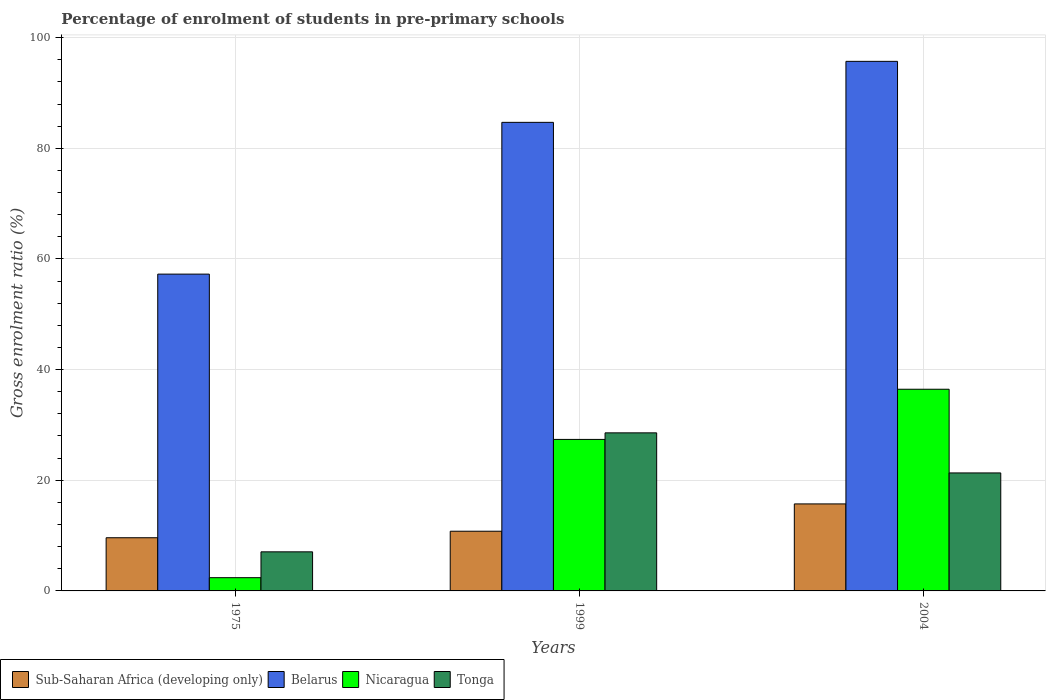How many different coloured bars are there?
Make the answer very short. 4. How many groups of bars are there?
Provide a short and direct response. 3. Are the number of bars per tick equal to the number of legend labels?
Provide a succinct answer. Yes. How many bars are there on the 1st tick from the left?
Offer a very short reply. 4. How many bars are there on the 2nd tick from the right?
Ensure brevity in your answer.  4. What is the label of the 1st group of bars from the left?
Your answer should be compact. 1975. In how many cases, is the number of bars for a given year not equal to the number of legend labels?
Offer a very short reply. 0. What is the percentage of students enrolled in pre-primary schools in Sub-Saharan Africa (developing only) in 1975?
Your response must be concise. 9.61. Across all years, what is the maximum percentage of students enrolled in pre-primary schools in Sub-Saharan Africa (developing only)?
Make the answer very short. 15.73. Across all years, what is the minimum percentage of students enrolled in pre-primary schools in Sub-Saharan Africa (developing only)?
Give a very brief answer. 9.61. In which year was the percentage of students enrolled in pre-primary schools in Sub-Saharan Africa (developing only) minimum?
Keep it short and to the point. 1975. What is the total percentage of students enrolled in pre-primary schools in Belarus in the graph?
Make the answer very short. 237.65. What is the difference between the percentage of students enrolled in pre-primary schools in Sub-Saharan Africa (developing only) in 1975 and that in 1999?
Ensure brevity in your answer.  -1.18. What is the difference between the percentage of students enrolled in pre-primary schools in Sub-Saharan Africa (developing only) in 1975 and the percentage of students enrolled in pre-primary schools in Nicaragua in 1999?
Provide a short and direct response. -17.77. What is the average percentage of students enrolled in pre-primary schools in Tonga per year?
Make the answer very short. 18.99. In the year 2004, what is the difference between the percentage of students enrolled in pre-primary schools in Belarus and percentage of students enrolled in pre-primary schools in Sub-Saharan Africa (developing only)?
Offer a terse response. 79.98. What is the ratio of the percentage of students enrolled in pre-primary schools in Nicaragua in 1999 to that in 2004?
Your response must be concise. 0.75. Is the difference between the percentage of students enrolled in pre-primary schools in Belarus in 1999 and 2004 greater than the difference between the percentage of students enrolled in pre-primary schools in Sub-Saharan Africa (developing only) in 1999 and 2004?
Offer a very short reply. No. What is the difference between the highest and the second highest percentage of students enrolled in pre-primary schools in Sub-Saharan Africa (developing only)?
Offer a very short reply. 4.94. What is the difference between the highest and the lowest percentage of students enrolled in pre-primary schools in Tonga?
Provide a short and direct response. 21.51. Is it the case that in every year, the sum of the percentage of students enrolled in pre-primary schools in Tonga and percentage of students enrolled in pre-primary schools in Sub-Saharan Africa (developing only) is greater than the sum of percentage of students enrolled in pre-primary schools in Belarus and percentage of students enrolled in pre-primary schools in Nicaragua?
Your answer should be compact. No. What does the 3rd bar from the left in 1975 represents?
Your answer should be very brief. Nicaragua. What does the 3rd bar from the right in 2004 represents?
Give a very brief answer. Belarus. Is it the case that in every year, the sum of the percentage of students enrolled in pre-primary schools in Sub-Saharan Africa (developing only) and percentage of students enrolled in pre-primary schools in Belarus is greater than the percentage of students enrolled in pre-primary schools in Tonga?
Ensure brevity in your answer.  Yes. What is the difference between two consecutive major ticks on the Y-axis?
Your answer should be very brief. 20. Does the graph contain any zero values?
Ensure brevity in your answer.  No. Does the graph contain grids?
Your answer should be compact. Yes. How many legend labels are there?
Your answer should be compact. 4. How are the legend labels stacked?
Provide a short and direct response. Horizontal. What is the title of the graph?
Keep it short and to the point. Percentage of enrolment of students in pre-primary schools. What is the label or title of the X-axis?
Keep it short and to the point. Years. What is the label or title of the Y-axis?
Give a very brief answer. Gross enrolment ratio (%). What is the Gross enrolment ratio (%) of Sub-Saharan Africa (developing only) in 1975?
Make the answer very short. 9.61. What is the Gross enrolment ratio (%) in Belarus in 1975?
Provide a succinct answer. 57.26. What is the Gross enrolment ratio (%) in Nicaragua in 1975?
Keep it short and to the point. 2.39. What is the Gross enrolment ratio (%) in Tonga in 1975?
Provide a succinct answer. 7.06. What is the Gross enrolment ratio (%) of Sub-Saharan Africa (developing only) in 1999?
Your response must be concise. 10.79. What is the Gross enrolment ratio (%) in Belarus in 1999?
Ensure brevity in your answer.  84.68. What is the Gross enrolment ratio (%) in Nicaragua in 1999?
Your answer should be very brief. 27.38. What is the Gross enrolment ratio (%) in Tonga in 1999?
Your answer should be compact. 28.57. What is the Gross enrolment ratio (%) in Sub-Saharan Africa (developing only) in 2004?
Offer a very short reply. 15.73. What is the Gross enrolment ratio (%) of Belarus in 2004?
Offer a very short reply. 95.71. What is the Gross enrolment ratio (%) in Nicaragua in 2004?
Keep it short and to the point. 36.45. What is the Gross enrolment ratio (%) of Tonga in 2004?
Provide a short and direct response. 21.32. Across all years, what is the maximum Gross enrolment ratio (%) of Sub-Saharan Africa (developing only)?
Provide a succinct answer. 15.73. Across all years, what is the maximum Gross enrolment ratio (%) of Belarus?
Ensure brevity in your answer.  95.71. Across all years, what is the maximum Gross enrolment ratio (%) in Nicaragua?
Keep it short and to the point. 36.45. Across all years, what is the maximum Gross enrolment ratio (%) in Tonga?
Offer a terse response. 28.57. Across all years, what is the minimum Gross enrolment ratio (%) of Sub-Saharan Africa (developing only)?
Ensure brevity in your answer.  9.61. Across all years, what is the minimum Gross enrolment ratio (%) in Belarus?
Ensure brevity in your answer.  57.26. Across all years, what is the minimum Gross enrolment ratio (%) of Nicaragua?
Ensure brevity in your answer.  2.39. Across all years, what is the minimum Gross enrolment ratio (%) of Tonga?
Provide a short and direct response. 7.06. What is the total Gross enrolment ratio (%) of Sub-Saharan Africa (developing only) in the graph?
Ensure brevity in your answer.  36.12. What is the total Gross enrolment ratio (%) of Belarus in the graph?
Keep it short and to the point. 237.65. What is the total Gross enrolment ratio (%) of Nicaragua in the graph?
Your answer should be very brief. 66.23. What is the total Gross enrolment ratio (%) in Tonga in the graph?
Ensure brevity in your answer.  56.96. What is the difference between the Gross enrolment ratio (%) of Sub-Saharan Africa (developing only) in 1975 and that in 1999?
Keep it short and to the point. -1.18. What is the difference between the Gross enrolment ratio (%) of Belarus in 1975 and that in 1999?
Offer a terse response. -27.43. What is the difference between the Gross enrolment ratio (%) of Nicaragua in 1975 and that in 1999?
Keep it short and to the point. -24.99. What is the difference between the Gross enrolment ratio (%) in Tonga in 1975 and that in 1999?
Your response must be concise. -21.5. What is the difference between the Gross enrolment ratio (%) in Sub-Saharan Africa (developing only) in 1975 and that in 2004?
Keep it short and to the point. -6.11. What is the difference between the Gross enrolment ratio (%) of Belarus in 1975 and that in 2004?
Give a very brief answer. -38.45. What is the difference between the Gross enrolment ratio (%) in Nicaragua in 1975 and that in 2004?
Your response must be concise. -34.06. What is the difference between the Gross enrolment ratio (%) in Tonga in 1975 and that in 2004?
Give a very brief answer. -14.26. What is the difference between the Gross enrolment ratio (%) of Sub-Saharan Africa (developing only) in 1999 and that in 2004?
Offer a terse response. -4.94. What is the difference between the Gross enrolment ratio (%) of Belarus in 1999 and that in 2004?
Your answer should be compact. -11.02. What is the difference between the Gross enrolment ratio (%) of Nicaragua in 1999 and that in 2004?
Give a very brief answer. -9.07. What is the difference between the Gross enrolment ratio (%) in Tonga in 1999 and that in 2004?
Make the answer very short. 7.25. What is the difference between the Gross enrolment ratio (%) of Sub-Saharan Africa (developing only) in 1975 and the Gross enrolment ratio (%) of Belarus in 1999?
Provide a short and direct response. -75.07. What is the difference between the Gross enrolment ratio (%) of Sub-Saharan Africa (developing only) in 1975 and the Gross enrolment ratio (%) of Nicaragua in 1999?
Your answer should be very brief. -17.77. What is the difference between the Gross enrolment ratio (%) of Sub-Saharan Africa (developing only) in 1975 and the Gross enrolment ratio (%) of Tonga in 1999?
Ensure brevity in your answer.  -18.96. What is the difference between the Gross enrolment ratio (%) of Belarus in 1975 and the Gross enrolment ratio (%) of Nicaragua in 1999?
Your answer should be very brief. 29.87. What is the difference between the Gross enrolment ratio (%) in Belarus in 1975 and the Gross enrolment ratio (%) in Tonga in 1999?
Give a very brief answer. 28.69. What is the difference between the Gross enrolment ratio (%) in Nicaragua in 1975 and the Gross enrolment ratio (%) in Tonga in 1999?
Your answer should be compact. -26.18. What is the difference between the Gross enrolment ratio (%) of Sub-Saharan Africa (developing only) in 1975 and the Gross enrolment ratio (%) of Belarus in 2004?
Offer a very short reply. -86.1. What is the difference between the Gross enrolment ratio (%) of Sub-Saharan Africa (developing only) in 1975 and the Gross enrolment ratio (%) of Nicaragua in 2004?
Provide a succinct answer. -26.84. What is the difference between the Gross enrolment ratio (%) of Sub-Saharan Africa (developing only) in 1975 and the Gross enrolment ratio (%) of Tonga in 2004?
Your answer should be very brief. -11.71. What is the difference between the Gross enrolment ratio (%) in Belarus in 1975 and the Gross enrolment ratio (%) in Nicaragua in 2004?
Make the answer very short. 20.81. What is the difference between the Gross enrolment ratio (%) of Belarus in 1975 and the Gross enrolment ratio (%) of Tonga in 2004?
Your response must be concise. 35.93. What is the difference between the Gross enrolment ratio (%) of Nicaragua in 1975 and the Gross enrolment ratio (%) of Tonga in 2004?
Give a very brief answer. -18.93. What is the difference between the Gross enrolment ratio (%) in Sub-Saharan Africa (developing only) in 1999 and the Gross enrolment ratio (%) in Belarus in 2004?
Give a very brief answer. -84.92. What is the difference between the Gross enrolment ratio (%) in Sub-Saharan Africa (developing only) in 1999 and the Gross enrolment ratio (%) in Nicaragua in 2004?
Your response must be concise. -25.66. What is the difference between the Gross enrolment ratio (%) of Sub-Saharan Africa (developing only) in 1999 and the Gross enrolment ratio (%) of Tonga in 2004?
Your response must be concise. -10.54. What is the difference between the Gross enrolment ratio (%) in Belarus in 1999 and the Gross enrolment ratio (%) in Nicaragua in 2004?
Provide a short and direct response. 48.23. What is the difference between the Gross enrolment ratio (%) of Belarus in 1999 and the Gross enrolment ratio (%) of Tonga in 2004?
Give a very brief answer. 63.36. What is the difference between the Gross enrolment ratio (%) of Nicaragua in 1999 and the Gross enrolment ratio (%) of Tonga in 2004?
Provide a succinct answer. 6.06. What is the average Gross enrolment ratio (%) in Sub-Saharan Africa (developing only) per year?
Keep it short and to the point. 12.04. What is the average Gross enrolment ratio (%) in Belarus per year?
Offer a terse response. 79.22. What is the average Gross enrolment ratio (%) of Nicaragua per year?
Give a very brief answer. 22.08. What is the average Gross enrolment ratio (%) in Tonga per year?
Your answer should be compact. 18.99. In the year 1975, what is the difference between the Gross enrolment ratio (%) of Sub-Saharan Africa (developing only) and Gross enrolment ratio (%) of Belarus?
Provide a short and direct response. -47.64. In the year 1975, what is the difference between the Gross enrolment ratio (%) in Sub-Saharan Africa (developing only) and Gross enrolment ratio (%) in Nicaragua?
Give a very brief answer. 7.22. In the year 1975, what is the difference between the Gross enrolment ratio (%) of Sub-Saharan Africa (developing only) and Gross enrolment ratio (%) of Tonga?
Provide a short and direct response. 2.55. In the year 1975, what is the difference between the Gross enrolment ratio (%) in Belarus and Gross enrolment ratio (%) in Nicaragua?
Offer a terse response. 54.86. In the year 1975, what is the difference between the Gross enrolment ratio (%) of Belarus and Gross enrolment ratio (%) of Tonga?
Keep it short and to the point. 50.19. In the year 1975, what is the difference between the Gross enrolment ratio (%) in Nicaragua and Gross enrolment ratio (%) in Tonga?
Your answer should be compact. -4.67. In the year 1999, what is the difference between the Gross enrolment ratio (%) in Sub-Saharan Africa (developing only) and Gross enrolment ratio (%) in Belarus?
Your answer should be very brief. -73.9. In the year 1999, what is the difference between the Gross enrolment ratio (%) of Sub-Saharan Africa (developing only) and Gross enrolment ratio (%) of Nicaragua?
Give a very brief answer. -16.6. In the year 1999, what is the difference between the Gross enrolment ratio (%) of Sub-Saharan Africa (developing only) and Gross enrolment ratio (%) of Tonga?
Provide a succinct answer. -17.78. In the year 1999, what is the difference between the Gross enrolment ratio (%) in Belarus and Gross enrolment ratio (%) in Nicaragua?
Offer a terse response. 57.3. In the year 1999, what is the difference between the Gross enrolment ratio (%) of Belarus and Gross enrolment ratio (%) of Tonga?
Make the answer very short. 56.12. In the year 1999, what is the difference between the Gross enrolment ratio (%) of Nicaragua and Gross enrolment ratio (%) of Tonga?
Your answer should be very brief. -1.19. In the year 2004, what is the difference between the Gross enrolment ratio (%) of Sub-Saharan Africa (developing only) and Gross enrolment ratio (%) of Belarus?
Offer a terse response. -79.98. In the year 2004, what is the difference between the Gross enrolment ratio (%) of Sub-Saharan Africa (developing only) and Gross enrolment ratio (%) of Nicaragua?
Provide a short and direct response. -20.73. In the year 2004, what is the difference between the Gross enrolment ratio (%) in Sub-Saharan Africa (developing only) and Gross enrolment ratio (%) in Tonga?
Your answer should be very brief. -5.6. In the year 2004, what is the difference between the Gross enrolment ratio (%) in Belarus and Gross enrolment ratio (%) in Nicaragua?
Your answer should be very brief. 59.26. In the year 2004, what is the difference between the Gross enrolment ratio (%) in Belarus and Gross enrolment ratio (%) in Tonga?
Provide a short and direct response. 74.38. In the year 2004, what is the difference between the Gross enrolment ratio (%) in Nicaragua and Gross enrolment ratio (%) in Tonga?
Keep it short and to the point. 15.13. What is the ratio of the Gross enrolment ratio (%) in Sub-Saharan Africa (developing only) in 1975 to that in 1999?
Ensure brevity in your answer.  0.89. What is the ratio of the Gross enrolment ratio (%) of Belarus in 1975 to that in 1999?
Offer a very short reply. 0.68. What is the ratio of the Gross enrolment ratio (%) in Nicaragua in 1975 to that in 1999?
Your response must be concise. 0.09. What is the ratio of the Gross enrolment ratio (%) in Tonga in 1975 to that in 1999?
Give a very brief answer. 0.25. What is the ratio of the Gross enrolment ratio (%) in Sub-Saharan Africa (developing only) in 1975 to that in 2004?
Make the answer very short. 0.61. What is the ratio of the Gross enrolment ratio (%) in Belarus in 1975 to that in 2004?
Keep it short and to the point. 0.6. What is the ratio of the Gross enrolment ratio (%) of Nicaragua in 1975 to that in 2004?
Make the answer very short. 0.07. What is the ratio of the Gross enrolment ratio (%) of Tonga in 1975 to that in 2004?
Offer a terse response. 0.33. What is the ratio of the Gross enrolment ratio (%) of Sub-Saharan Africa (developing only) in 1999 to that in 2004?
Make the answer very short. 0.69. What is the ratio of the Gross enrolment ratio (%) in Belarus in 1999 to that in 2004?
Offer a very short reply. 0.88. What is the ratio of the Gross enrolment ratio (%) of Nicaragua in 1999 to that in 2004?
Your response must be concise. 0.75. What is the ratio of the Gross enrolment ratio (%) in Tonga in 1999 to that in 2004?
Offer a very short reply. 1.34. What is the difference between the highest and the second highest Gross enrolment ratio (%) of Sub-Saharan Africa (developing only)?
Keep it short and to the point. 4.94. What is the difference between the highest and the second highest Gross enrolment ratio (%) in Belarus?
Ensure brevity in your answer.  11.02. What is the difference between the highest and the second highest Gross enrolment ratio (%) in Nicaragua?
Your answer should be very brief. 9.07. What is the difference between the highest and the second highest Gross enrolment ratio (%) in Tonga?
Your response must be concise. 7.25. What is the difference between the highest and the lowest Gross enrolment ratio (%) of Sub-Saharan Africa (developing only)?
Provide a short and direct response. 6.11. What is the difference between the highest and the lowest Gross enrolment ratio (%) of Belarus?
Provide a short and direct response. 38.45. What is the difference between the highest and the lowest Gross enrolment ratio (%) of Nicaragua?
Offer a very short reply. 34.06. What is the difference between the highest and the lowest Gross enrolment ratio (%) of Tonga?
Ensure brevity in your answer.  21.5. 